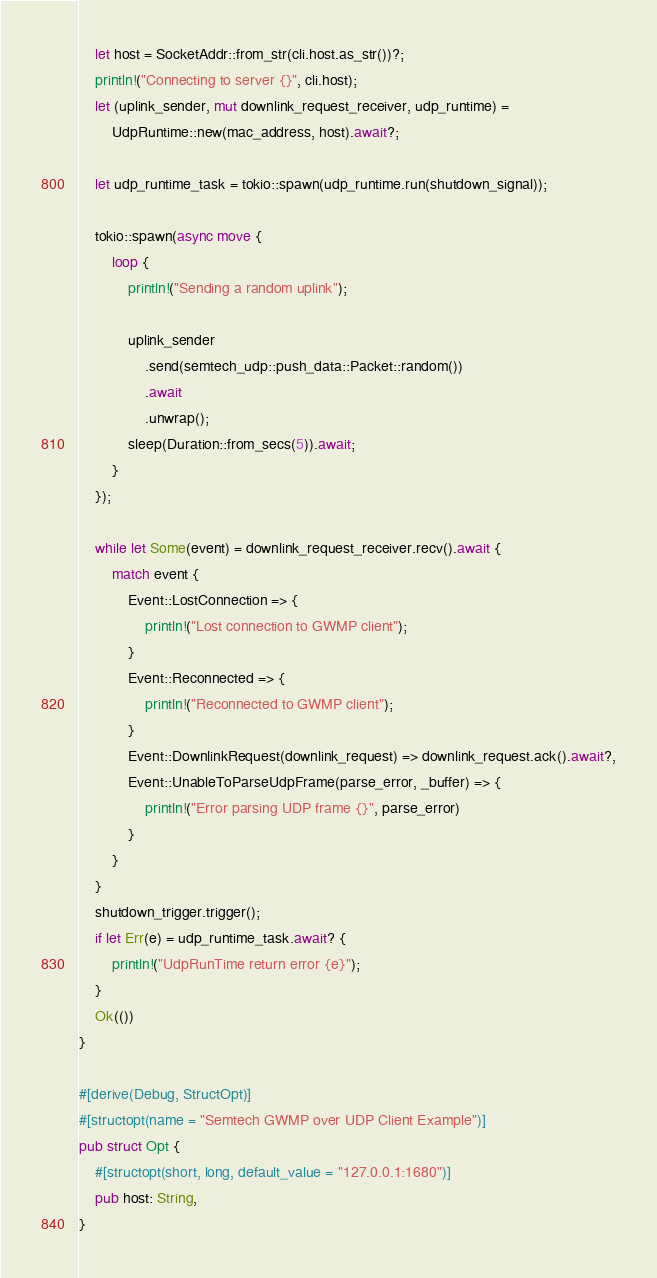Convert code to text. <code><loc_0><loc_0><loc_500><loc_500><_Rust_>    let host = SocketAddr::from_str(cli.host.as_str())?;
    println!("Connecting to server {}", cli.host);
    let (uplink_sender, mut downlink_request_receiver, udp_runtime) =
        UdpRuntime::new(mac_address, host).await?;

    let udp_runtime_task = tokio::spawn(udp_runtime.run(shutdown_signal));

    tokio::spawn(async move {
        loop {
            println!("Sending a random uplink");

            uplink_sender
                .send(semtech_udp::push_data::Packet::random())
                .await
                .unwrap();
            sleep(Duration::from_secs(5)).await;
        }
    });

    while let Some(event) = downlink_request_receiver.recv().await {
        match event {
            Event::LostConnection => {
                println!("Lost connection to GWMP client");
            }
            Event::Reconnected => {
                println!("Reconnected to GWMP client");
            }
            Event::DownlinkRequest(downlink_request) => downlink_request.ack().await?,
            Event::UnableToParseUdpFrame(parse_error, _buffer) => {
                println!("Error parsing UDP frame {}", parse_error)
            }
        }
    }
    shutdown_trigger.trigger();
    if let Err(e) = udp_runtime_task.await? {
        println!("UdpRunTime return error {e}");
    }
    Ok(())
}

#[derive(Debug, StructOpt)]
#[structopt(name = "Semtech GWMP over UDP Client Example")]
pub struct Opt {
    #[structopt(short, long, default_value = "127.0.0.1:1680")]
    pub host: String,
}
</code> 